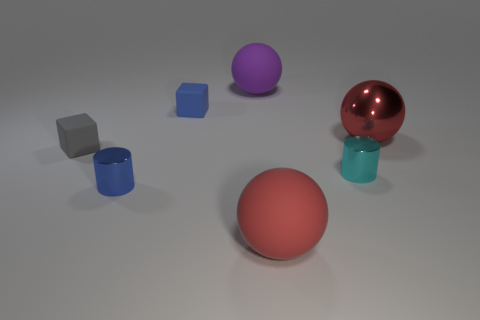Is there a red metallic thing that has the same shape as the tiny cyan thing?
Your answer should be very brief. No. There is a large rubber object that is behind the big red thing that is in front of the gray block; what color is it?
Your answer should be very brief. Purple. Is the number of tiny things greater than the number of small blue rubber blocks?
Your response must be concise. Yes. How many red matte spheres are the same size as the blue cylinder?
Your answer should be very brief. 0. Does the cyan object have the same material as the tiny block on the left side of the blue cube?
Your response must be concise. No. Is the number of small things less than the number of gray matte blocks?
Keep it short and to the point. No. Is there anything else that has the same color as the big metallic ball?
Ensure brevity in your answer.  Yes. The cyan object that is the same material as the small blue cylinder is what shape?
Offer a very short reply. Cylinder. How many blue metal things are to the right of the rubber sphere in front of the tiny block to the left of the blue matte cube?
Offer a terse response. 0. The small object that is both to the left of the blue rubber block and behind the cyan shiny cylinder has what shape?
Give a very brief answer. Cube. 